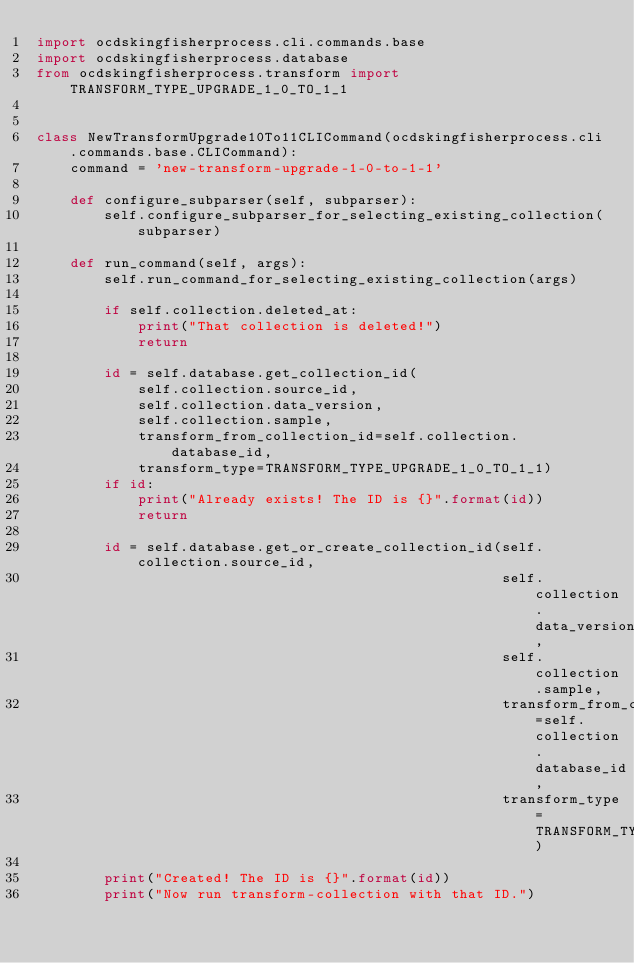<code> <loc_0><loc_0><loc_500><loc_500><_Python_>import ocdskingfisherprocess.cli.commands.base
import ocdskingfisherprocess.database
from ocdskingfisherprocess.transform import TRANSFORM_TYPE_UPGRADE_1_0_TO_1_1


class NewTransformUpgrade10To11CLICommand(ocdskingfisherprocess.cli.commands.base.CLICommand):
    command = 'new-transform-upgrade-1-0-to-1-1'

    def configure_subparser(self, subparser):
        self.configure_subparser_for_selecting_existing_collection(subparser)

    def run_command(self, args):
        self.run_command_for_selecting_existing_collection(args)

        if self.collection.deleted_at:
            print("That collection is deleted!")
            return

        id = self.database.get_collection_id(
            self.collection.source_id,
            self.collection.data_version,
            self.collection.sample,
            transform_from_collection_id=self.collection.database_id,
            transform_type=TRANSFORM_TYPE_UPGRADE_1_0_TO_1_1)
        if id:
            print("Already exists! The ID is {}".format(id))
            return

        id = self.database.get_or_create_collection_id(self.collection.source_id,
                                                       self.collection.data_version,
                                                       self.collection.sample,
                                                       transform_from_collection_id=self.collection.database_id,
                                                       transform_type=TRANSFORM_TYPE_UPGRADE_1_0_TO_1_1)

        print("Created! The ID is {}".format(id))
        print("Now run transform-collection with that ID.")
</code> 